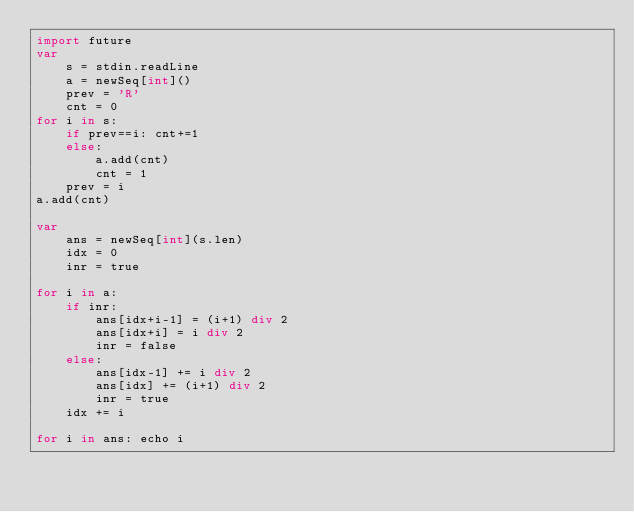Convert code to text. <code><loc_0><loc_0><loc_500><loc_500><_Nim_>import future
var
    s = stdin.readLine
    a = newSeq[int]()
    prev = 'R'
    cnt = 0
for i in s:
    if prev==i: cnt+=1
    else:
        a.add(cnt)
        cnt = 1
    prev = i
a.add(cnt)

var
    ans = newSeq[int](s.len)
    idx = 0
    inr = true

for i in a:
    if inr:
        ans[idx+i-1] = (i+1) div 2
        ans[idx+i] = i div 2
        inr = false
    else:
        ans[idx-1] += i div 2
        ans[idx] += (i+1) div 2
        inr = true
    idx += i

for i in ans: echo i</code> 